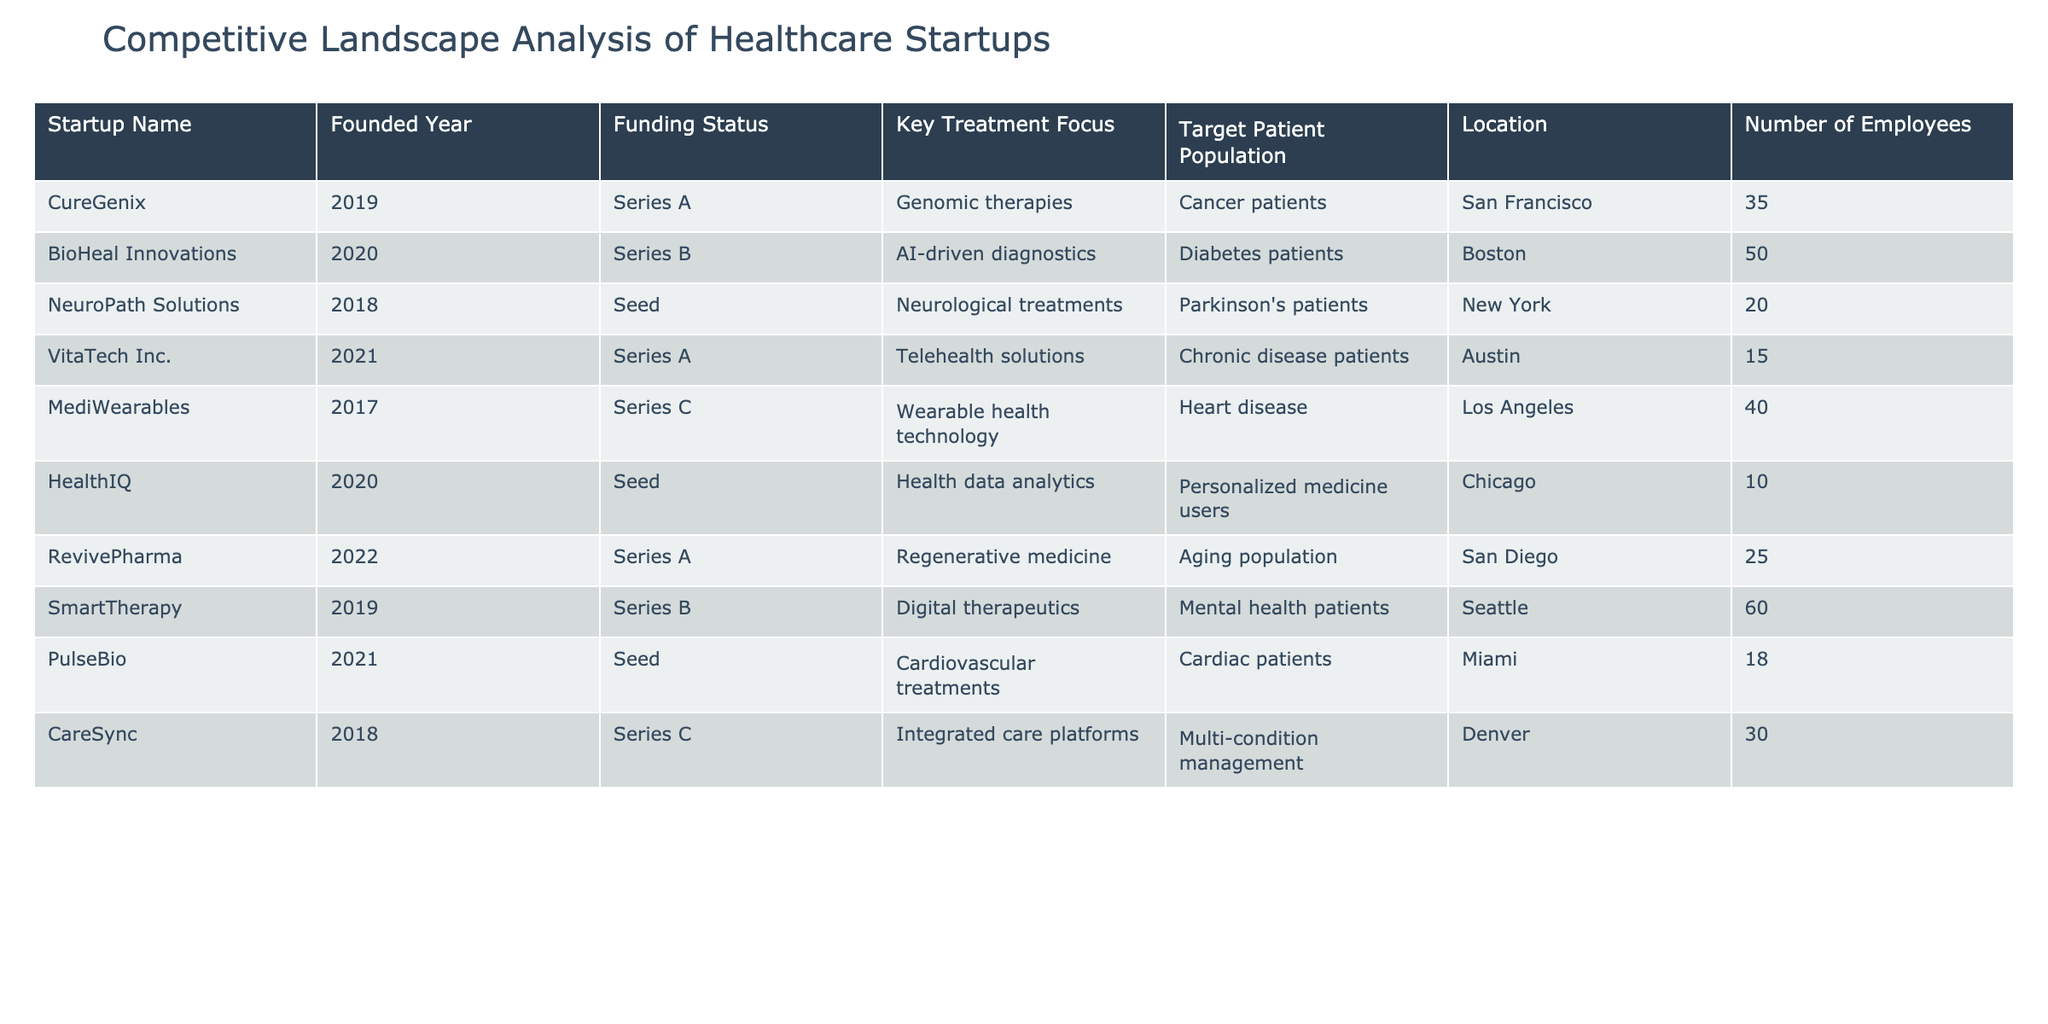What is the key treatment focus of CureGenix? CureGenix is focused on genomic therapies, as listed in the table under "Key Treatment Focus."
Answer: Genomic therapies Which startup has the largest number of employees? By inspecting the "Number of Employees" column, SmartTherapy has 60 employees, the maximum in the list.
Answer: 60 How many startups were founded in 2020? There are two startups from 2020: BioHeal Innovations and HealthIQ, making the count 2.
Answer: 2 Is there any startup focused on telehealth solutions? Yes, VitaTech Inc. is noted for its focus on telehealth solutions, confirming the presence of this treatment area in the table.
Answer: Yes What is the average number of employees for startups founded in 2018? The two startups founded in 2018 (NeuroPath Solutions with 20 employees and CareSync with 30 employees) have an average of (20 + 30) / 2 = 25 employees.
Answer: 25 Which startup targets the aging population? RevivePharma specifically targets the aging population, according to the "Target Patient Population" provided in the table.
Answer: RevivePharma How many total startups focus on diagnostics or therapy solutions? The startups focused on diagnostics or therapy solutions are BioHeal Innovations (AI-driven diagnostics), SmartTherapy (digital therapeutics), and CureGenix (genomic therapies), totaling 3 startups.
Answer: 3 Do any startups have a funding status of Seed? Yes, there are three startups with a Seed funding status: NeuroPath Solutions, HealthIQ, and PulseBio.
Answer: Yes Which two locations contain startups focusing on cardiovascular treatments? PulseBio (Miami) and MediWearables (Los Angeles) are the two startups that focus on cardiovascular treatments and their respective locations.
Answer: Miami and Los Angeles What is the difference in the number of employees between the largest and smallest startup? The largest startup is SmartTherapy with 60 employees, and the smallest is HealthIQ with 10 employees. The difference is 60 - 10 = 50 employees.
Answer: 50 Which startup secured Series C funding, and what is its treatment focus? MediWearables secured Series C funding, and its treatment focus is wearable health technology, as noted in the funding and key treatment columns.
Answer: MediWearables, wearable health technology 